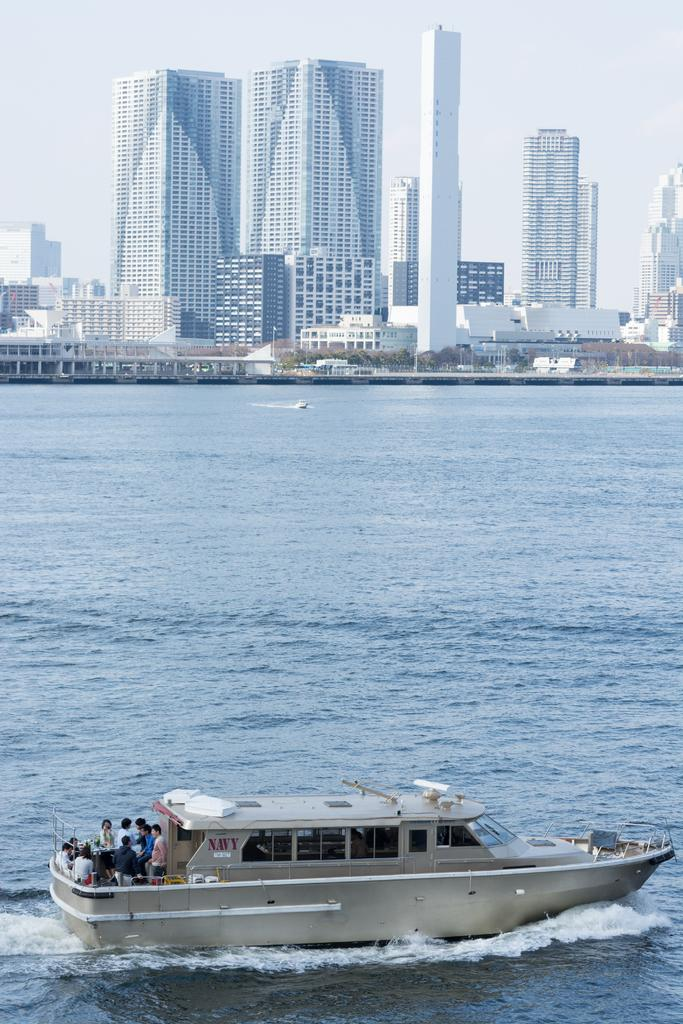What activity are the people in the image engaged in? The people in the image are sailing a boat. Where is the boat located in the image? The boat is on the water. What structures can be seen in the background of the image? There are buildings visible in the image. What type of vegetation is present in the image? Trees are present in the image. What part of the natural environment is visible in the image? The sky is visible in the image. What type of hook is being used by the people sailing the boat in the image? There is no hook visible in the image; the people are sailing a boat without any visible fishing equipment. 